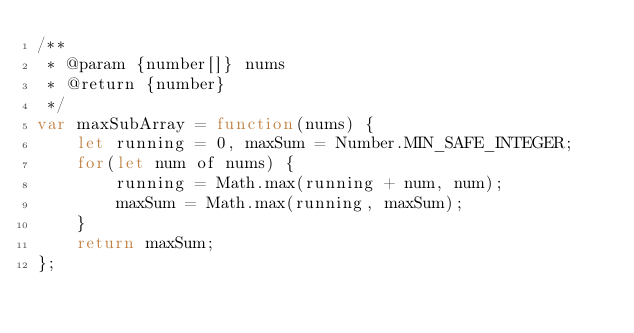<code> <loc_0><loc_0><loc_500><loc_500><_JavaScript_>/**
 * @param {number[]} nums
 * @return {number}
 */
var maxSubArray = function(nums) {
    let running = 0, maxSum = Number.MIN_SAFE_INTEGER;
    for(let num of nums) {
        running = Math.max(running + num, num);
        maxSum = Math.max(running, maxSum);
    }
    return maxSum;
};
</code> 